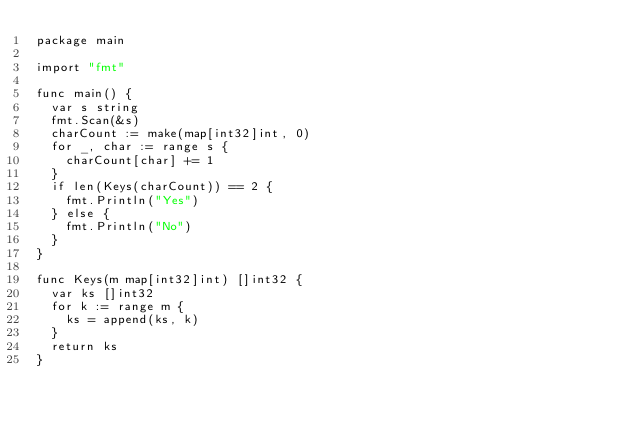Convert code to text. <code><loc_0><loc_0><loc_500><loc_500><_Go_>package main

import "fmt"

func main() {
	var s string
	fmt.Scan(&s)
	charCount := make(map[int32]int, 0)
	for _, char := range s {
		charCount[char] += 1
	}
	if len(Keys(charCount)) == 2 {
		fmt.Println("Yes")
	} else {
		fmt.Println("No")
	}
}

func Keys(m map[int32]int) []int32 {
	var ks []int32
	for k := range m {
		ks = append(ks, k)
	}
	return ks
}
</code> 